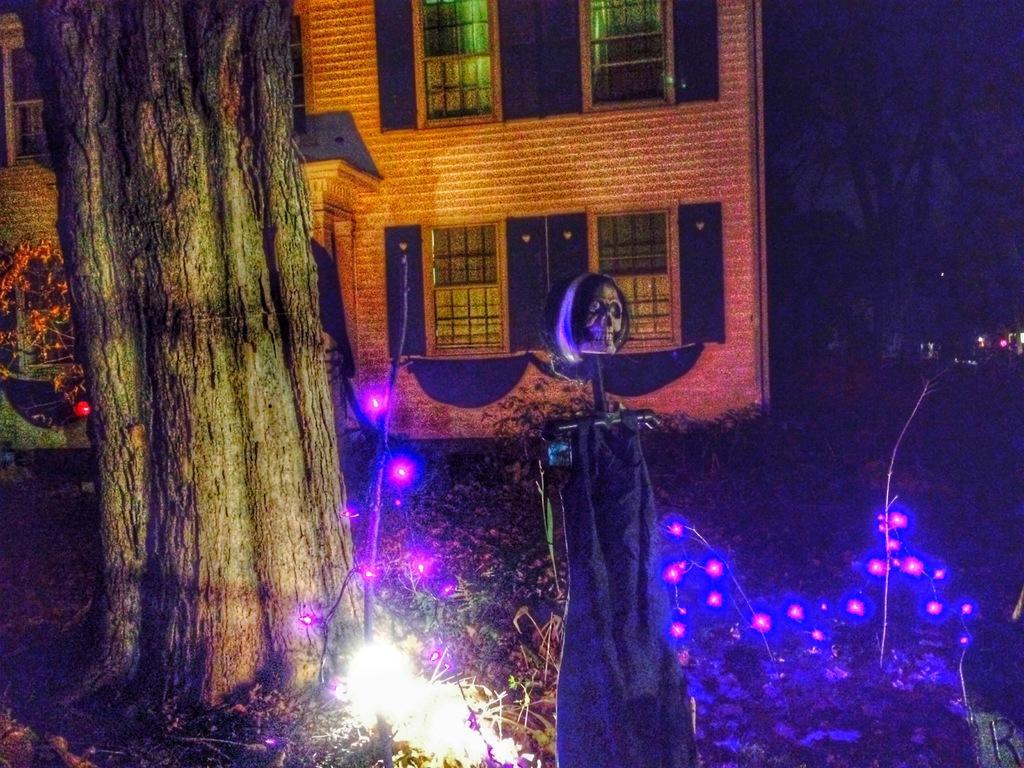Could you give a brief overview of what you see in this image? In this picture I can observe lights in the bottom of the picture. On the left side I can observe tree. In the background there is a building. 